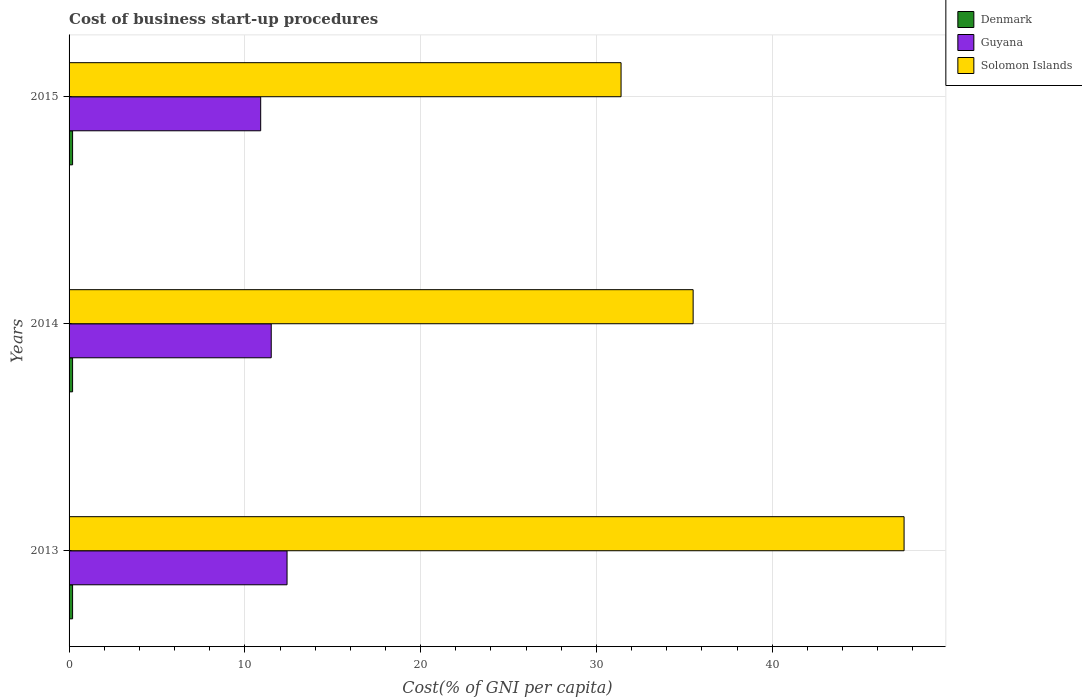How many groups of bars are there?
Keep it short and to the point. 3. Are the number of bars on each tick of the Y-axis equal?
Your answer should be very brief. Yes. How many bars are there on the 2nd tick from the bottom?
Offer a terse response. 3. What is the cost of business start-up procedures in Solomon Islands in 2014?
Ensure brevity in your answer.  35.5. Across all years, what is the maximum cost of business start-up procedures in Guyana?
Provide a short and direct response. 12.4. In which year was the cost of business start-up procedures in Guyana minimum?
Provide a short and direct response. 2015. What is the total cost of business start-up procedures in Denmark in the graph?
Provide a succinct answer. 0.6. What is the difference between the cost of business start-up procedures in Denmark in 2014 and the cost of business start-up procedures in Guyana in 2013?
Offer a terse response. -12.2. In the year 2014, what is the difference between the cost of business start-up procedures in Guyana and cost of business start-up procedures in Denmark?
Provide a succinct answer. 11.3. What is the ratio of the cost of business start-up procedures in Denmark in 2013 to that in 2014?
Give a very brief answer. 1. What is the difference between the highest and the second highest cost of business start-up procedures in Denmark?
Provide a succinct answer. 0. In how many years, is the cost of business start-up procedures in Denmark greater than the average cost of business start-up procedures in Denmark taken over all years?
Make the answer very short. 0. Is the sum of the cost of business start-up procedures in Guyana in 2013 and 2015 greater than the maximum cost of business start-up procedures in Denmark across all years?
Offer a terse response. Yes. What does the 3rd bar from the top in 2014 represents?
Offer a terse response. Denmark. What does the 3rd bar from the bottom in 2013 represents?
Make the answer very short. Solomon Islands. Is it the case that in every year, the sum of the cost of business start-up procedures in Denmark and cost of business start-up procedures in Solomon Islands is greater than the cost of business start-up procedures in Guyana?
Give a very brief answer. Yes. Are all the bars in the graph horizontal?
Provide a short and direct response. Yes. How many years are there in the graph?
Your answer should be compact. 3. Does the graph contain any zero values?
Make the answer very short. No. Where does the legend appear in the graph?
Your response must be concise. Top right. How are the legend labels stacked?
Provide a short and direct response. Vertical. What is the title of the graph?
Ensure brevity in your answer.  Cost of business start-up procedures. What is the label or title of the X-axis?
Ensure brevity in your answer.  Cost(% of GNI per capita). What is the label or title of the Y-axis?
Keep it short and to the point. Years. What is the Cost(% of GNI per capita) of Denmark in 2013?
Offer a very short reply. 0.2. What is the Cost(% of GNI per capita) in Guyana in 2013?
Make the answer very short. 12.4. What is the Cost(% of GNI per capita) of Solomon Islands in 2013?
Offer a very short reply. 47.5. What is the Cost(% of GNI per capita) of Solomon Islands in 2014?
Make the answer very short. 35.5. What is the Cost(% of GNI per capita) of Denmark in 2015?
Give a very brief answer. 0.2. What is the Cost(% of GNI per capita) of Solomon Islands in 2015?
Keep it short and to the point. 31.4. Across all years, what is the maximum Cost(% of GNI per capita) in Solomon Islands?
Ensure brevity in your answer.  47.5. Across all years, what is the minimum Cost(% of GNI per capita) in Solomon Islands?
Provide a short and direct response. 31.4. What is the total Cost(% of GNI per capita) of Denmark in the graph?
Keep it short and to the point. 0.6. What is the total Cost(% of GNI per capita) of Guyana in the graph?
Give a very brief answer. 34.8. What is the total Cost(% of GNI per capita) of Solomon Islands in the graph?
Offer a very short reply. 114.4. What is the difference between the Cost(% of GNI per capita) of Denmark in 2013 and that in 2014?
Provide a succinct answer. 0. What is the difference between the Cost(% of GNI per capita) of Guyana in 2013 and that in 2014?
Provide a succinct answer. 0.9. What is the difference between the Cost(% of GNI per capita) in Solomon Islands in 2013 and that in 2014?
Ensure brevity in your answer.  12. What is the difference between the Cost(% of GNI per capita) in Denmark in 2013 and that in 2015?
Your answer should be compact. 0. What is the difference between the Cost(% of GNI per capita) in Guyana in 2013 and that in 2015?
Offer a terse response. 1.5. What is the difference between the Cost(% of GNI per capita) in Denmark in 2014 and that in 2015?
Make the answer very short. 0. What is the difference between the Cost(% of GNI per capita) of Guyana in 2014 and that in 2015?
Give a very brief answer. 0.6. What is the difference between the Cost(% of GNI per capita) of Solomon Islands in 2014 and that in 2015?
Keep it short and to the point. 4.1. What is the difference between the Cost(% of GNI per capita) of Denmark in 2013 and the Cost(% of GNI per capita) of Guyana in 2014?
Your answer should be compact. -11.3. What is the difference between the Cost(% of GNI per capita) of Denmark in 2013 and the Cost(% of GNI per capita) of Solomon Islands in 2014?
Offer a very short reply. -35.3. What is the difference between the Cost(% of GNI per capita) in Guyana in 2013 and the Cost(% of GNI per capita) in Solomon Islands in 2014?
Keep it short and to the point. -23.1. What is the difference between the Cost(% of GNI per capita) of Denmark in 2013 and the Cost(% of GNI per capita) of Guyana in 2015?
Provide a succinct answer. -10.7. What is the difference between the Cost(% of GNI per capita) in Denmark in 2013 and the Cost(% of GNI per capita) in Solomon Islands in 2015?
Give a very brief answer. -31.2. What is the difference between the Cost(% of GNI per capita) of Denmark in 2014 and the Cost(% of GNI per capita) of Guyana in 2015?
Ensure brevity in your answer.  -10.7. What is the difference between the Cost(% of GNI per capita) in Denmark in 2014 and the Cost(% of GNI per capita) in Solomon Islands in 2015?
Give a very brief answer. -31.2. What is the difference between the Cost(% of GNI per capita) in Guyana in 2014 and the Cost(% of GNI per capita) in Solomon Islands in 2015?
Offer a terse response. -19.9. What is the average Cost(% of GNI per capita) of Denmark per year?
Make the answer very short. 0.2. What is the average Cost(% of GNI per capita) of Solomon Islands per year?
Your response must be concise. 38.13. In the year 2013, what is the difference between the Cost(% of GNI per capita) of Denmark and Cost(% of GNI per capita) of Guyana?
Make the answer very short. -12.2. In the year 2013, what is the difference between the Cost(% of GNI per capita) in Denmark and Cost(% of GNI per capita) in Solomon Islands?
Your answer should be compact. -47.3. In the year 2013, what is the difference between the Cost(% of GNI per capita) in Guyana and Cost(% of GNI per capita) in Solomon Islands?
Give a very brief answer. -35.1. In the year 2014, what is the difference between the Cost(% of GNI per capita) of Denmark and Cost(% of GNI per capita) of Guyana?
Your answer should be very brief. -11.3. In the year 2014, what is the difference between the Cost(% of GNI per capita) in Denmark and Cost(% of GNI per capita) in Solomon Islands?
Make the answer very short. -35.3. In the year 2015, what is the difference between the Cost(% of GNI per capita) in Denmark and Cost(% of GNI per capita) in Solomon Islands?
Your answer should be compact. -31.2. In the year 2015, what is the difference between the Cost(% of GNI per capita) of Guyana and Cost(% of GNI per capita) of Solomon Islands?
Your answer should be compact. -20.5. What is the ratio of the Cost(% of GNI per capita) of Denmark in 2013 to that in 2014?
Your response must be concise. 1. What is the ratio of the Cost(% of GNI per capita) in Guyana in 2013 to that in 2014?
Offer a terse response. 1.08. What is the ratio of the Cost(% of GNI per capita) of Solomon Islands in 2013 to that in 2014?
Your response must be concise. 1.34. What is the ratio of the Cost(% of GNI per capita) in Guyana in 2013 to that in 2015?
Make the answer very short. 1.14. What is the ratio of the Cost(% of GNI per capita) in Solomon Islands in 2013 to that in 2015?
Make the answer very short. 1.51. What is the ratio of the Cost(% of GNI per capita) in Guyana in 2014 to that in 2015?
Provide a succinct answer. 1.05. What is the ratio of the Cost(% of GNI per capita) in Solomon Islands in 2014 to that in 2015?
Provide a succinct answer. 1.13. What is the difference between the highest and the second highest Cost(% of GNI per capita) of Denmark?
Offer a terse response. 0. What is the difference between the highest and the lowest Cost(% of GNI per capita) in Denmark?
Ensure brevity in your answer.  0. What is the difference between the highest and the lowest Cost(% of GNI per capita) of Solomon Islands?
Provide a succinct answer. 16.1. 